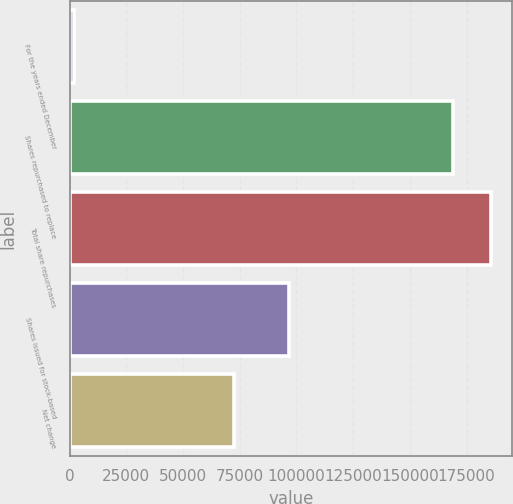Convert chart. <chart><loc_0><loc_0><loc_500><loc_500><bar_chart><fcel>For the years ended December<fcel>Shares repurchased to replace<fcel>Total share repurchases<fcel>Shares issued for stock-based<fcel>Net change<nl><fcel>2010<fcel>169099<fcel>185808<fcel>96627<fcel>72472<nl></chart> 